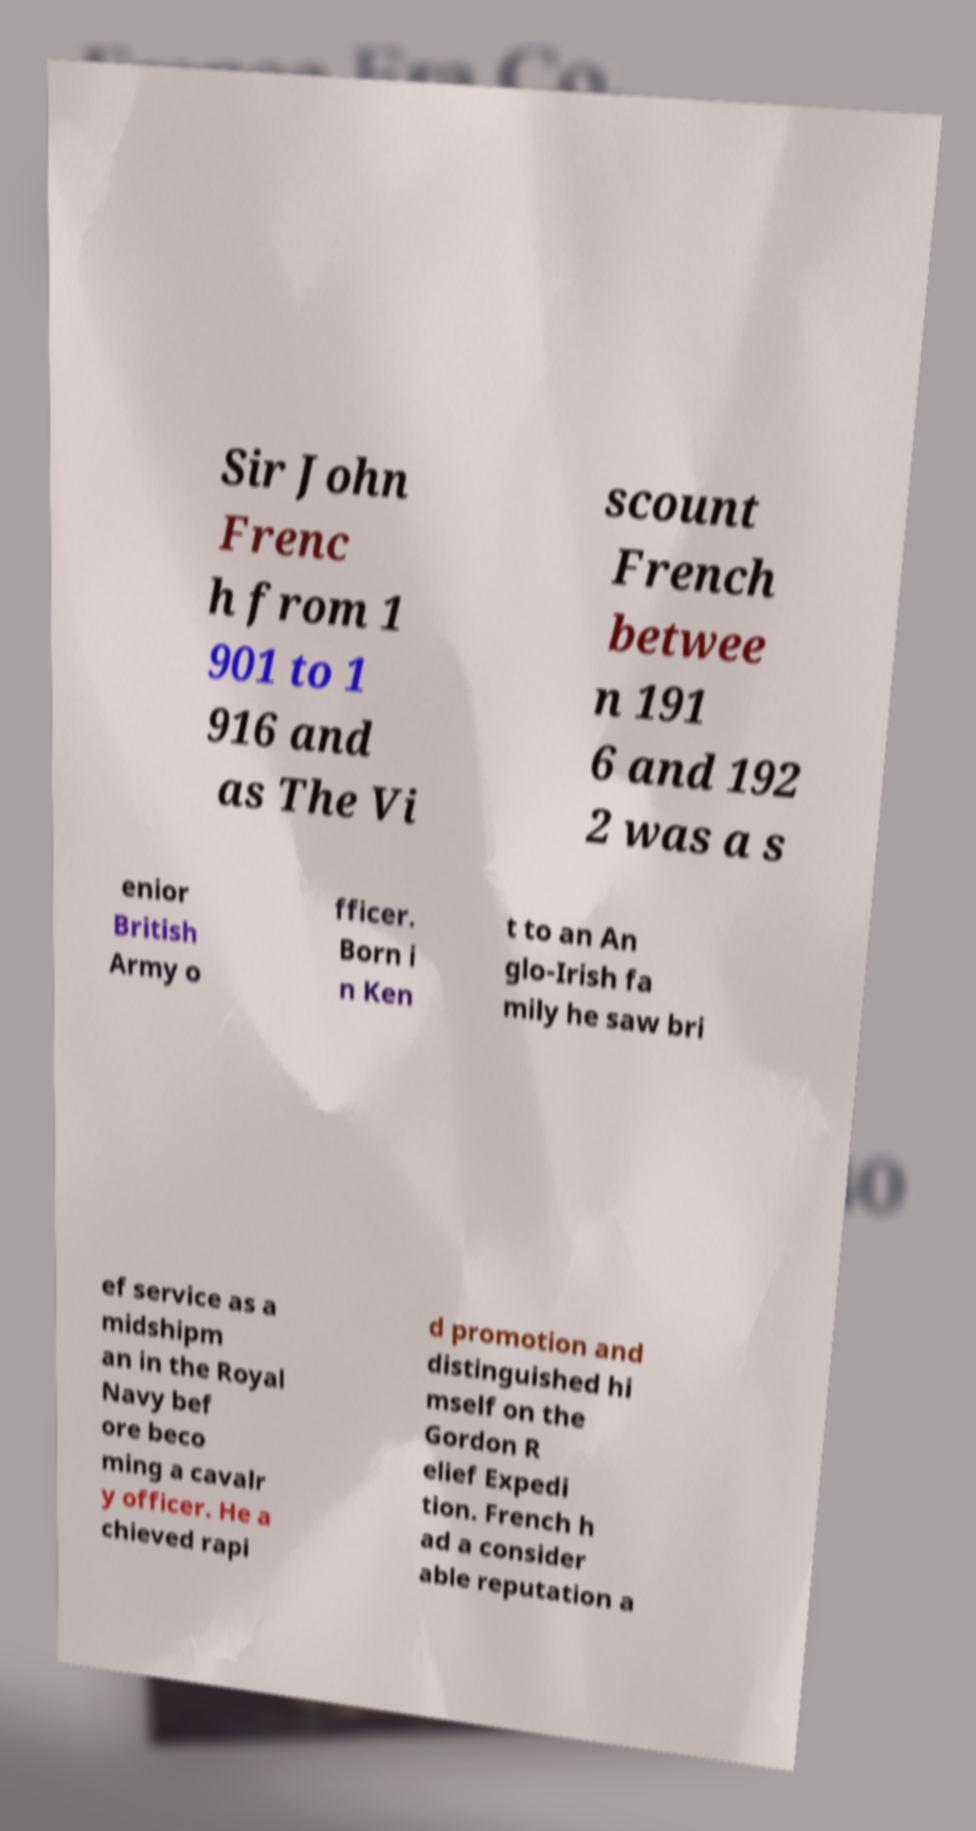Can you accurately transcribe the text from the provided image for me? Sir John Frenc h from 1 901 to 1 916 and as The Vi scount French betwee n 191 6 and 192 2 was a s enior British Army o fficer. Born i n Ken t to an An glo-Irish fa mily he saw bri ef service as a midshipm an in the Royal Navy bef ore beco ming a cavalr y officer. He a chieved rapi d promotion and distinguished hi mself on the Gordon R elief Expedi tion. French h ad a consider able reputation a 